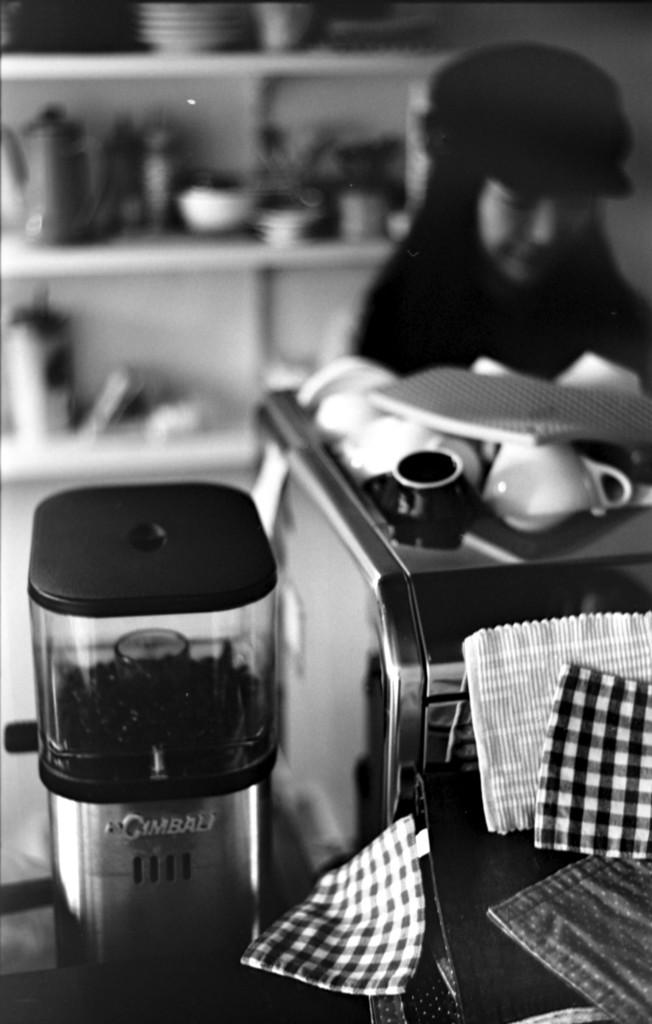<image>
Create a compact narrative representing the image presented. A blurred black and white photo shows some kind of appliance by Cimbali or Gimbali. 